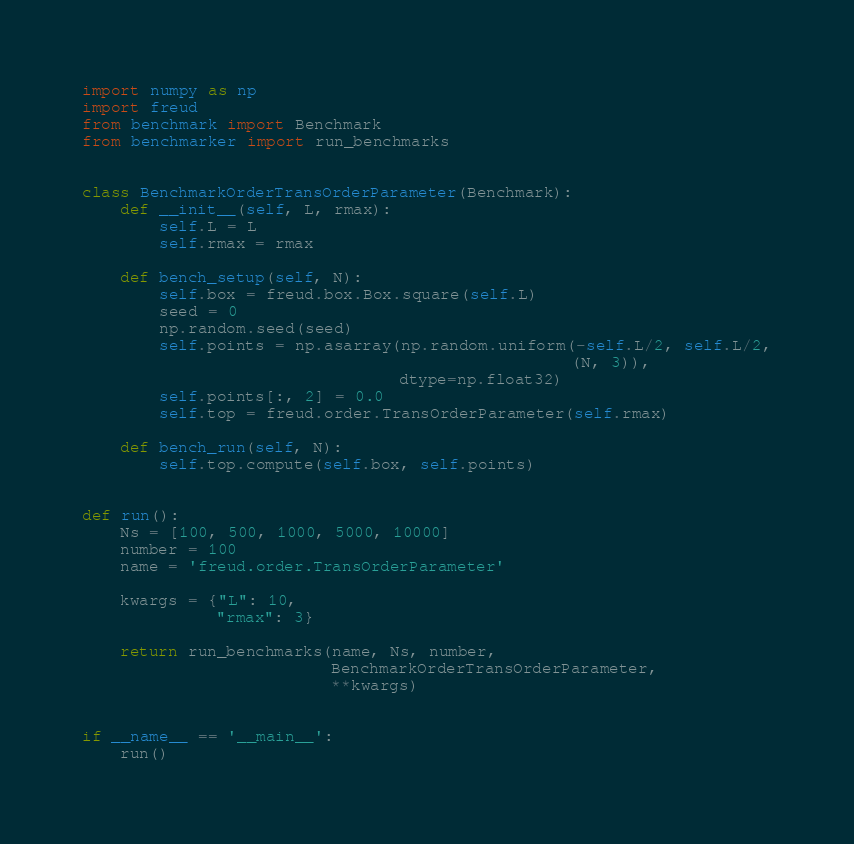Convert code to text. <code><loc_0><loc_0><loc_500><loc_500><_Python_>import numpy as np
import freud
from benchmark import Benchmark
from benchmarker import run_benchmarks


class BenchmarkOrderTransOrderParameter(Benchmark):
    def __init__(self, L, rmax):
        self.L = L
        self.rmax = rmax

    def bench_setup(self, N):
        self.box = freud.box.Box.square(self.L)
        seed = 0
        np.random.seed(seed)
        self.points = np.asarray(np.random.uniform(-self.L/2, self.L/2,
                                                   (N, 3)),
                                 dtype=np.float32)
        self.points[:, 2] = 0.0
        self.top = freud.order.TransOrderParameter(self.rmax)

    def bench_run(self, N):
        self.top.compute(self.box, self.points)


def run():
    Ns = [100, 500, 1000, 5000, 10000]
    number = 100
    name = 'freud.order.TransOrderParameter'

    kwargs = {"L": 10,
              "rmax": 3}

    return run_benchmarks(name, Ns, number,
                          BenchmarkOrderTransOrderParameter,
                          **kwargs)


if __name__ == '__main__':
    run()
</code> 